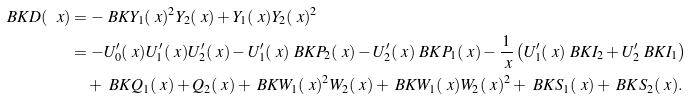Convert formula to latex. <formula><loc_0><loc_0><loc_500><loc_500>\ B K { D ( \ x ) } & = - \ B K { Y _ { 1 } ( \ x ) ^ { 2 } { Y } _ { 2 } ( \ x ) + Y _ { 1 } ( \ x ) { Y } _ { 2 } ( \ x ) ^ { 2 } } \\ & = - U ^ { \prime } _ { 0 } ( \ x ) U ^ { \prime } _ { 1 } ( \ x ) U ^ { \prime } _ { 2 } ( \ x ) - U ^ { \prime } _ { 1 } ( \ x ) \ B K { { P } _ { 2 } ( \ x ) } - U ^ { \prime } _ { 2 } ( \ x ) \ B K { P _ { 1 } ( \ x ) } - \frac { 1 } { \ x } \left ( U ^ { \prime } _ { 1 } ( \ x ) \ B K { { I } _ { 2 } } + U ^ { \prime } _ { 2 } \ B K { I _ { 1 } } \right ) \\ & \quad + \ B K { Q _ { 1 } ( \ x ) + { Q } _ { 2 } ( \ x ) } + \ B K { W _ { 1 } ( \ x ) ^ { 2 } { W } _ { 2 } ( \ x ) } + \ B K { W _ { 1 } ( \ x ) { W } _ { 2 } ( \ x ) ^ { 2 } } + \ B K { S _ { 1 } ( \ x ) } + \ B K { { S } _ { 2 } ( \ x ) } .</formula> 